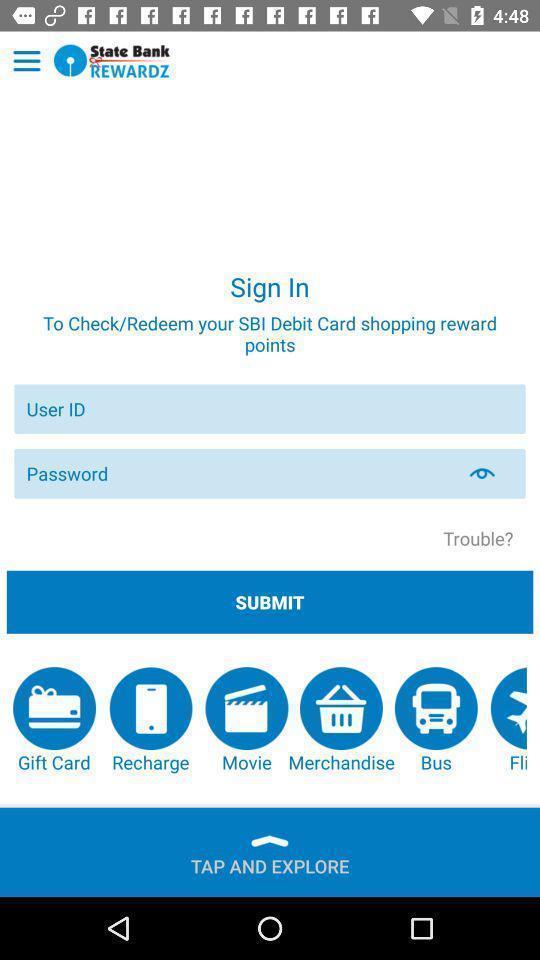Please provide a description for this image. Sign up page of a bank app. 